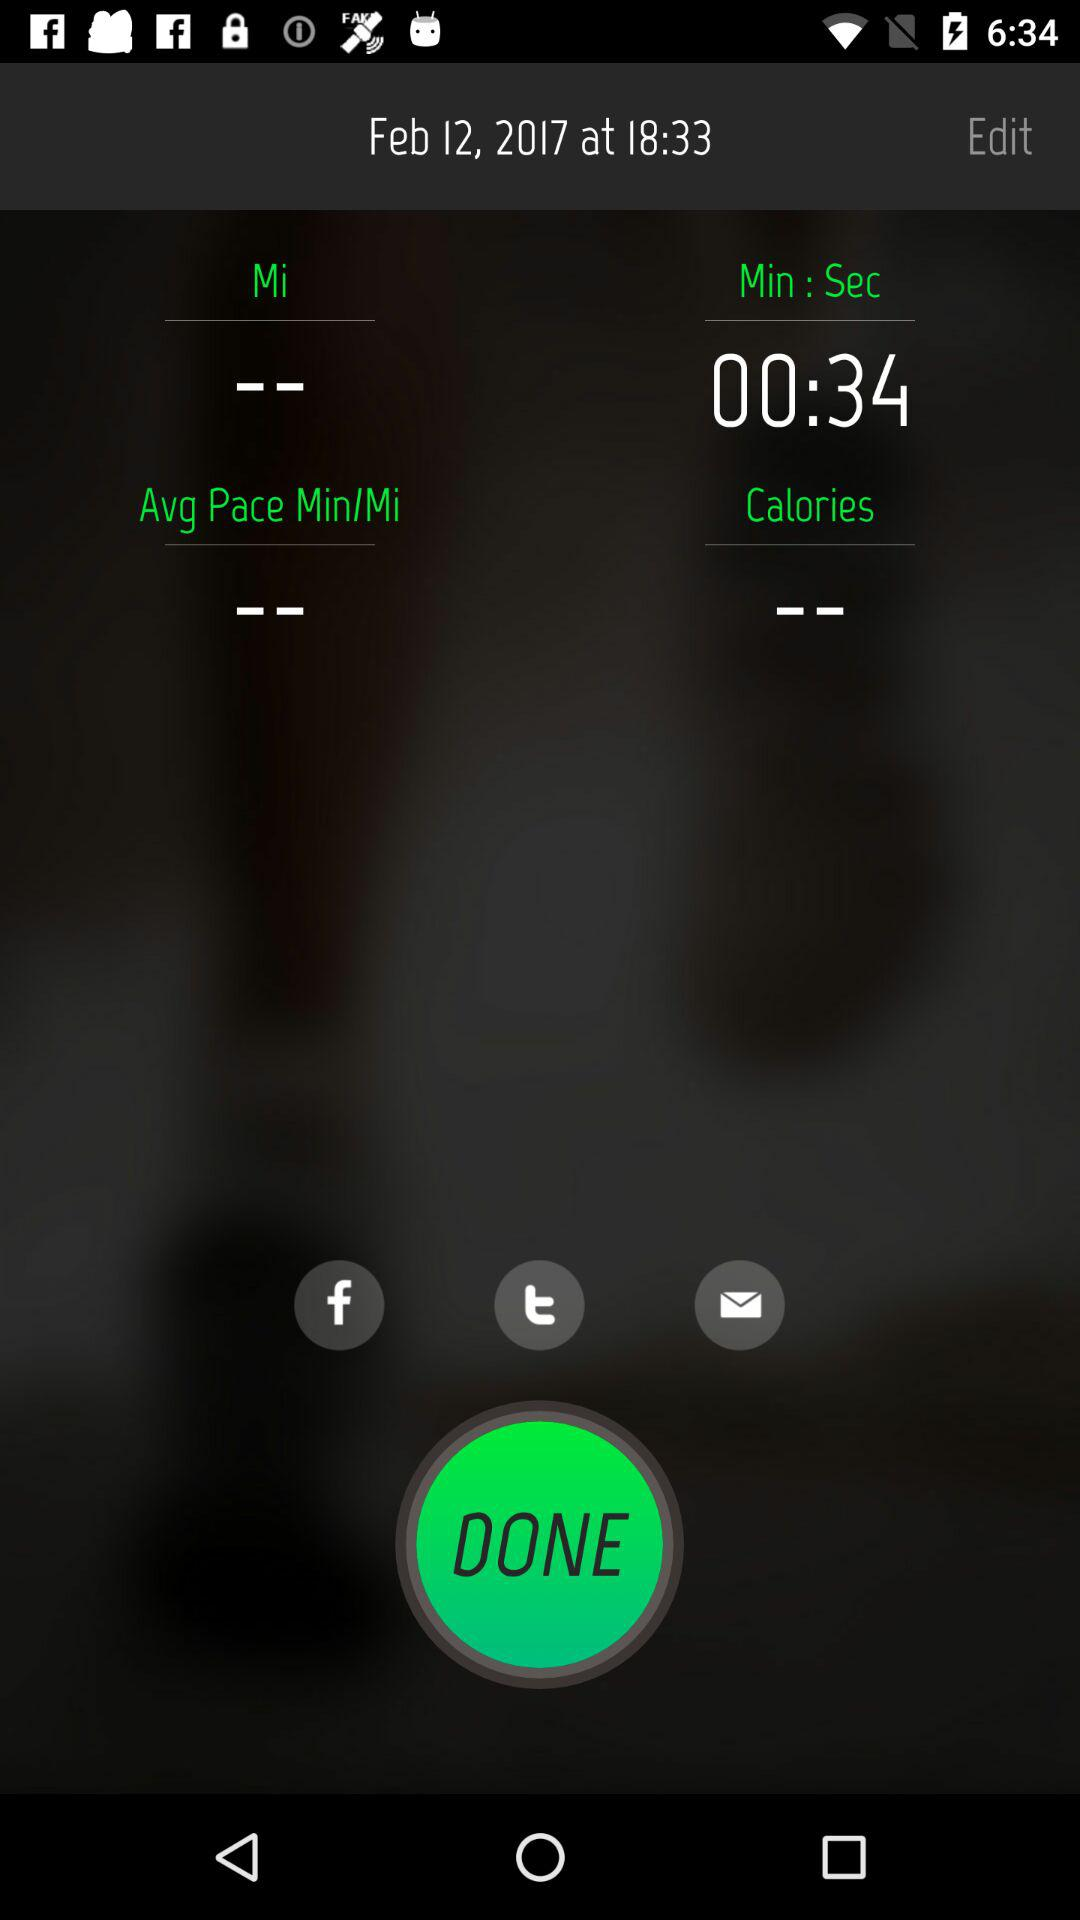How much time did the user spend on this activity?
Answer the question using a single word or phrase. 00:34 